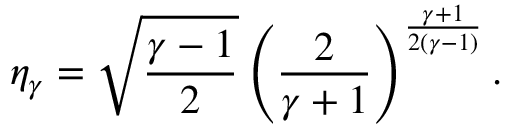Convert formula to latex. <formula><loc_0><loc_0><loc_500><loc_500>\eta _ { \gamma } = \sqrt { \frac { \gamma - 1 } { 2 } } \left ( \frac { 2 } { \gamma + 1 } \right ) ^ { \frac { \gamma + 1 } { 2 ( \gamma - 1 ) } } .</formula> 